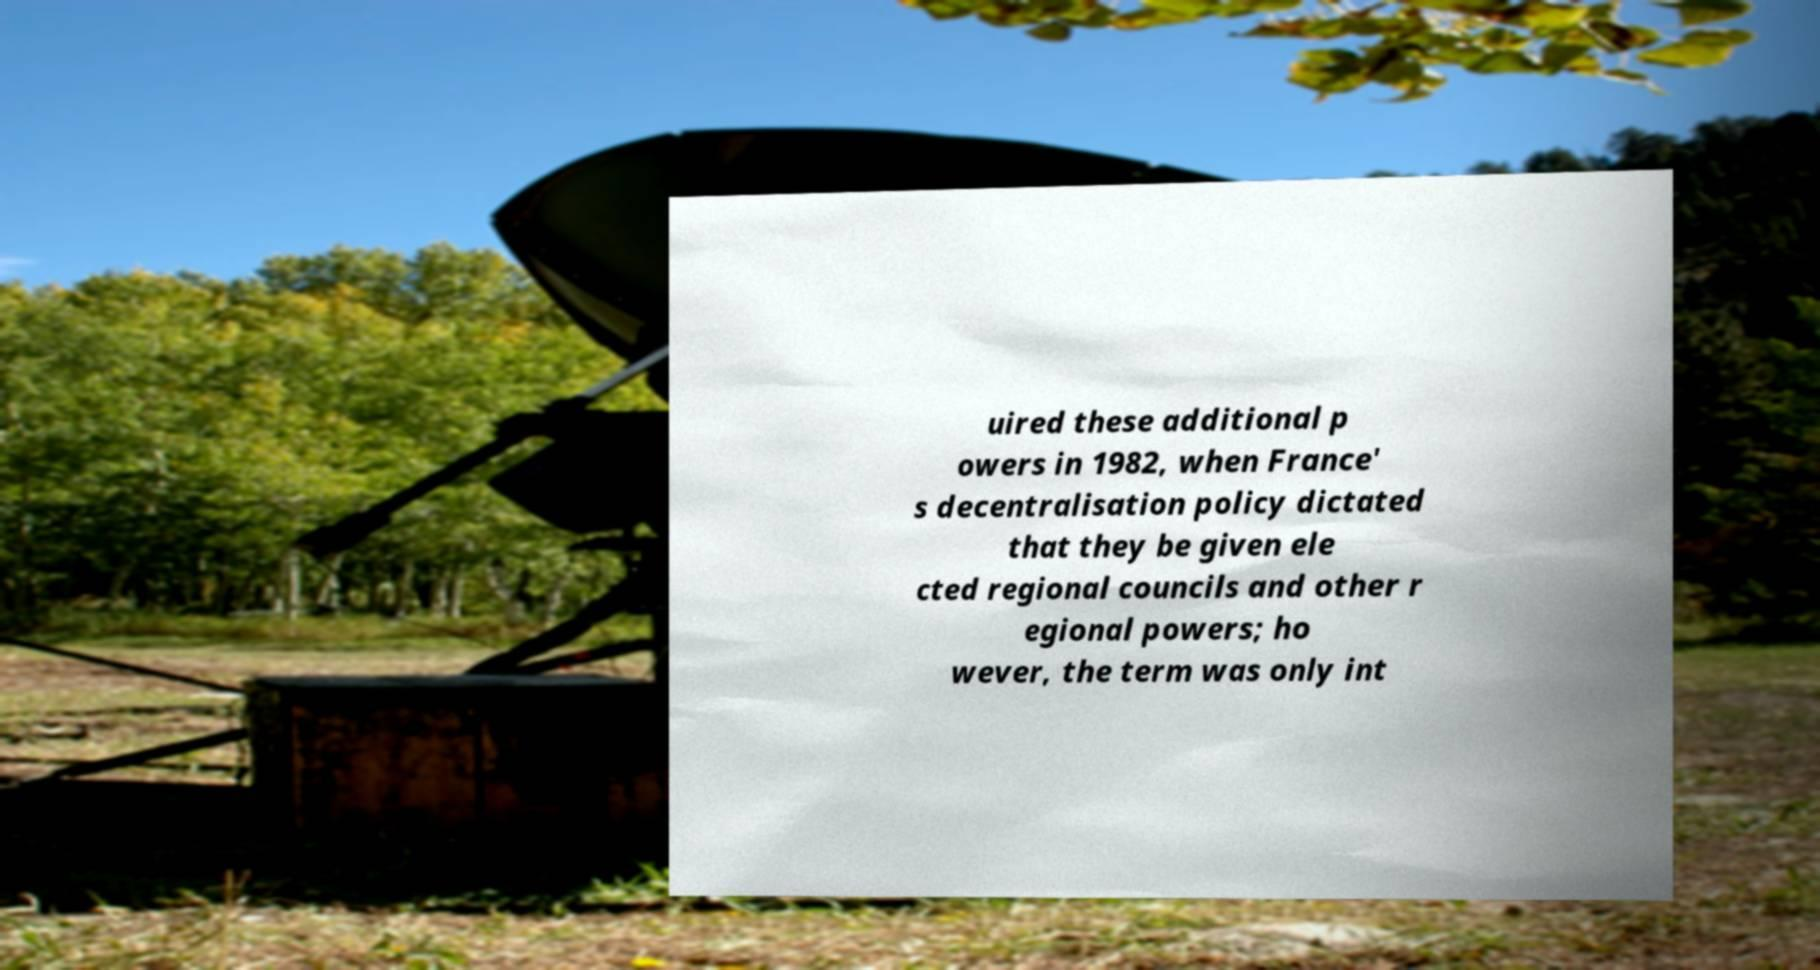Can you accurately transcribe the text from the provided image for me? uired these additional p owers in 1982, when France' s decentralisation policy dictated that they be given ele cted regional councils and other r egional powers; ho wever, the term was only int 